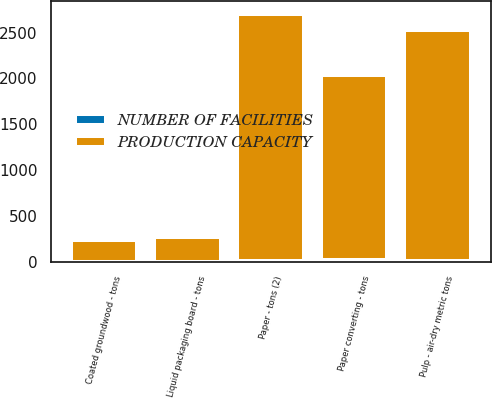<chart> <loc_0><loc_0><loc_500><loc_500><stacked_bar_chart><ecel><fcel>Pulp - air-dry metric tons<fcel>Paper - tons (2)<fcel>Coated groundwood - tons<fcel>Liquid packaging board - tons<fcel>Paper converting - tons<nl><fcel>PRODUCTION CAPACITY<fcel>2520<fcel>2700<fcel>235<fcel>270<fcel>2020<nl><fcel>NUMBER OF FACILITIES<fcel>10<fcel>7<fcel>1<fcel>1<fcel>16<nl></chart> 